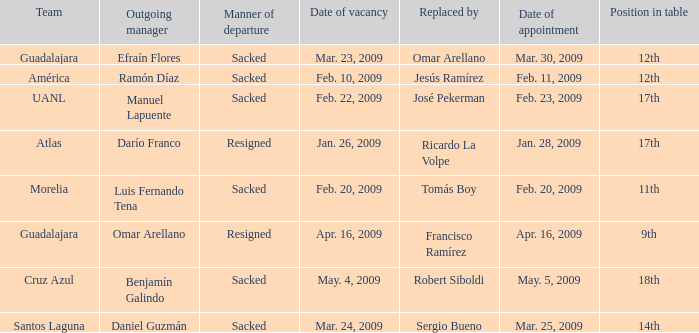What is Position in Table, when Replaced by is "José Pekerman"? 17th. 